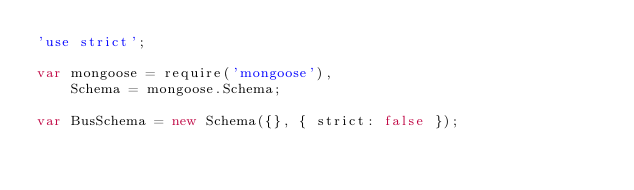<code> <loc_0><loc_0><loc_500><loc_500><_JavaScript_>'use strict';

var mongoose = require('mongoose'),
    Schema = mongoose.Schema;

var BusSchema = new Schema({}, { strict: false });
</code> 